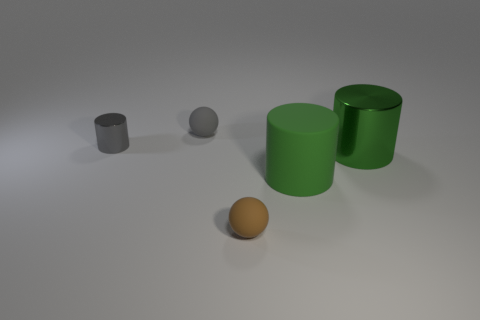Does the big matte object have the same color as the large metallic object?
Ensure brevity in your answer.  Yes. There is a large cylinder that is the same material as the small gray sphere; what color is it?
Your response must be concise. Green. Is the number of tiny brown spheres that are behind the big metallic thing less than the number of gray cylinders?
Keep it short and to the point. Yes. There is a green cylinder to the left of the metal thing on the right side of the ball that is in front of the gray metallic cylinder; how big is it?
Keep it short and to the point. Large. Do the ball that is behind the small brown object and the small brown ball have the same material?
Offer a terse response. Yes. There is another big object that is the same color as the big metal thing; what is its material?
Keep it short and to the point. Rubber. How many things are tiny gray spheres or yellow blocks?
Ensure brevity in your answer.  1. The green matte object that is the same shape as the small gray metal object is what size?
Give a very brief answer. Large. What number of blocks are gray rubber objects or tiny gray things?
Keep it short and to the point. 0. What is the color of the tiny thing that is on the right side of the small thing that is behind the small shiny cylinder?
Keep it short and to the point. Brown. 